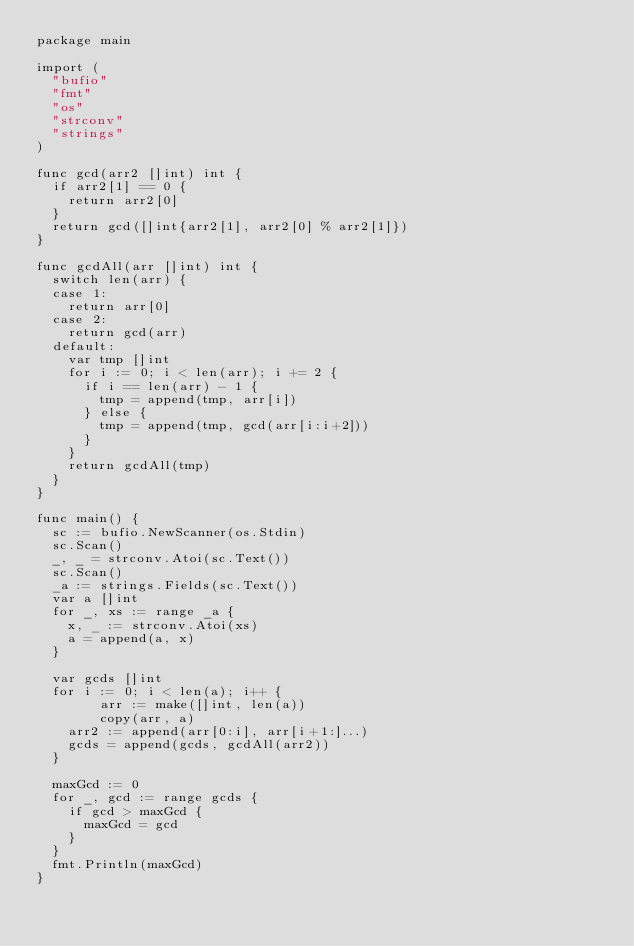<code> <loc_0><loc_0><loc_500><loc_500><_Go_>package main

import (
	"bufio"
	"fmt"
	"os"
	"strconv"
	"strings"
)

func gcd(arr2 []int) int {
	if arr2[1] == 0 {
		return arr2[0]
	}
	return gcd([]int{arr2[1], arr2[0] % arr2[1]})
}

func gcdAll(arr []int) int {
	switch len(arr) {
	case 1:
		return arr[0]
	case 2:
		return gcd(arr)
	default:
		var tmp []int
		for i := 0; i < len(arr); i += 2 {
			if i == len(arr) - 1 {
				tmp = append(tmp, arr[i])
			} else {
				tmp = append(tmp, gcd(arr[i:i+2]))
			}
		}
		return gcdAll(tmp)
	}
}

func main() {
	sc := bufio.NewScanner(os.Stdin)
	sc.Scan()
	_, _ = strconv.Atoi(sc.Text())
	sc.Scan()
	_a := strings.Fields(sc.Text())
	var a []int
	for _, xs := range _a {
		x, _ := strconv.Atoi(xs)
		a = append(a, x)
	}

	var gcds []int
	for i := 0; i < len(a); i++ {
        arr := make([]int, len(a))
        copy(arr, a)
		arr2 := append(arr[0:i], arr[i+1:]...)
		gcds = append(gcds, gcdAll(arr2))
	}

	maxGcd := 0
	for _, gcd := range gcds {
		if gcd > maxGcd {
			maxGcd = gcd
		}
	}
	fmt.Println(maxGcd)
}</code> 